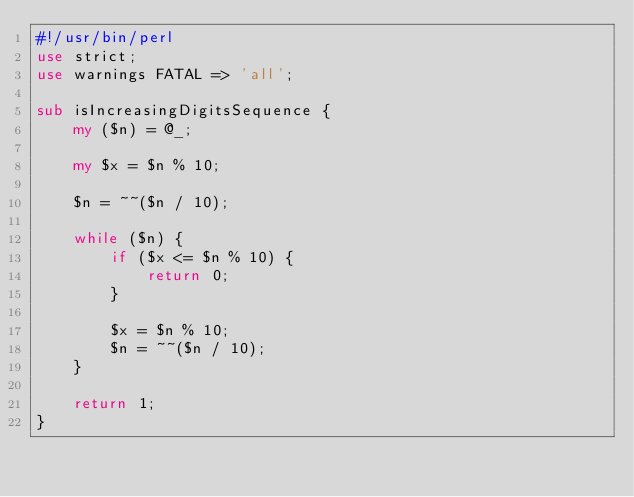<code> <loc_0><loc_0><loc_500><loc_500><_Perl_>#!/usr/bin/perl
use strict;
use warnings FATAL => 'all';

sub isIncreasingDigitsSequence {
    my ($n) = @_;

    my $x = $n % 10;

    $n = ~~($n / 10);

    while ($n) {
        if ($x <= $n % 10) {
            return 0;
        }

        $x = $n % 10;
        $n = ~~($n / 10);
    }

    return 1;
}
</code> 